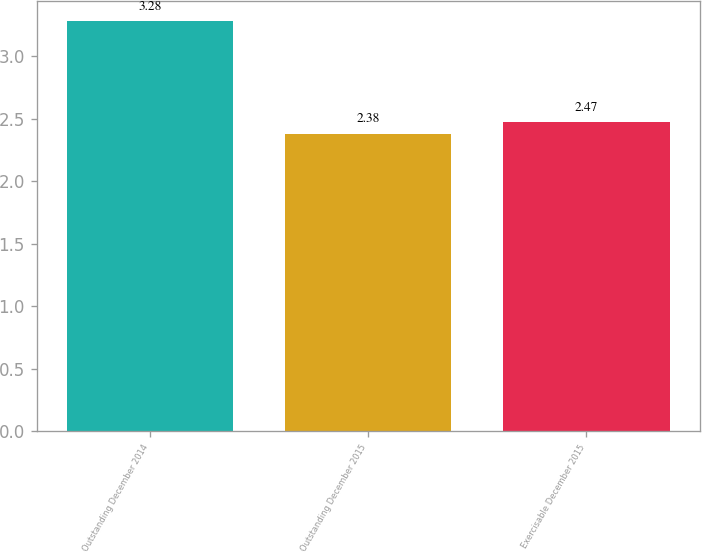Convert chart. <chart><loc_0><loc_0><loc_500><loc_500><bar_chart><fcel>Outstanding December 2014<fcel>Outstanding December 2015<fcel>Exercisable December 2015<nl><fcel>3.28<fcel>2.38<fcel>2.47<nl></chart> 